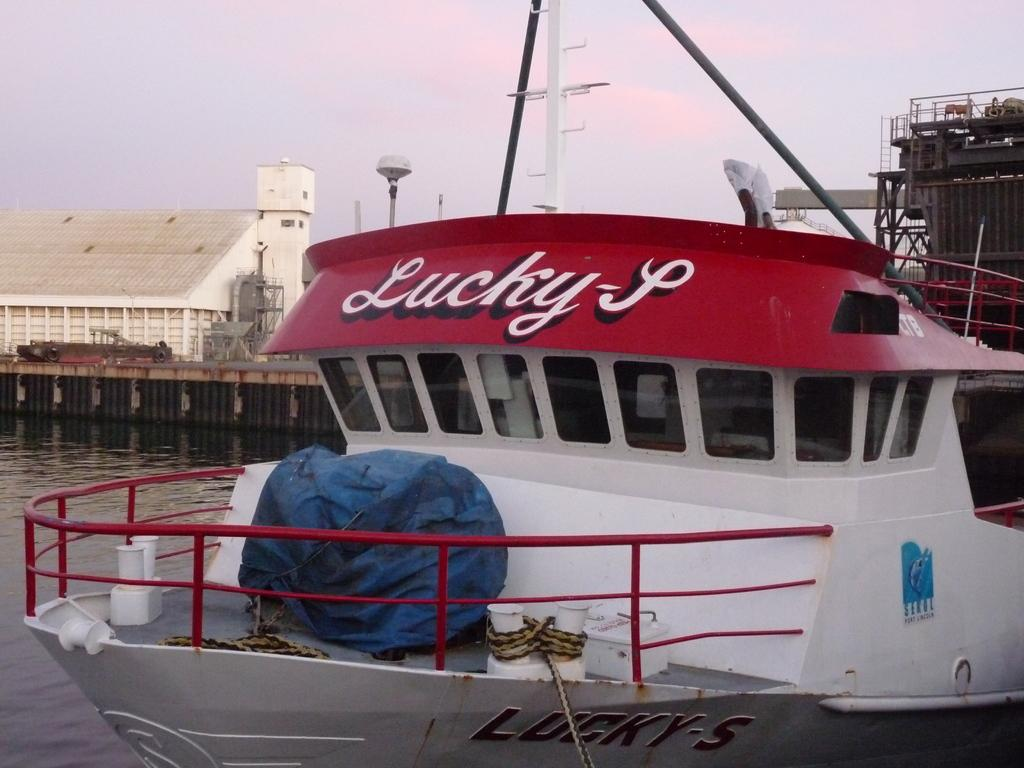What is the main subject of the image? The main subject of the image is a boat. What color is the boat? The boat is white in color. What can be seen on the left side of the image? There is water on the left side of the image. What is visible at the top of the image? The sky is visible at the top of the image. How many feet of paint are required to cover the boat in the image? There is no information about painting the boat in the image, and therefore we cannot determine the amount of paint required. Can you see any cherries on the boat in the image? There are no cherries present in the image; the main subject is a white boat. 